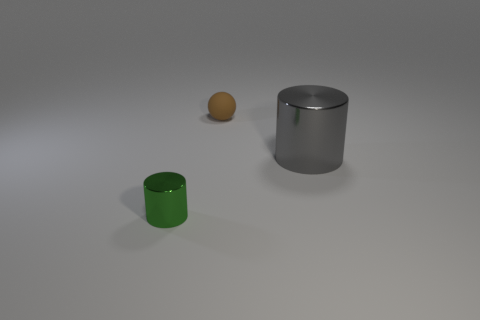Could you describe the lighting and shadows in the image? Certainly, the lighting in the image appears to be coming from above, as indicated by the shadows cast directly underneath the objects. The diffuse nature of the shadows suggests a soft and indirect light source, which is typical of a studio environment. There is a gentle gradient of light falling off across the surface, highlighting the contours and textures of the objects, and providing depth to the scene. The contrast between light and shadow adds a three-dimensional quality to the objects, making them stand out against the neutral background. 